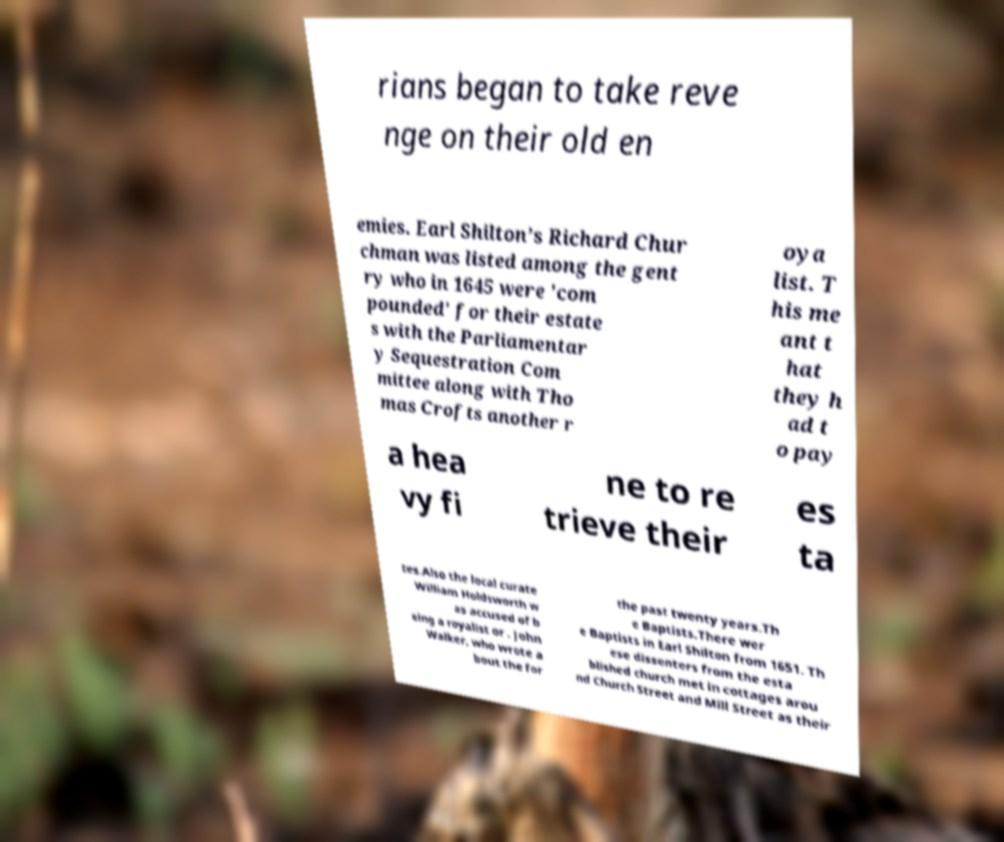Please identify and transcribe the text found in this image. rians began to take reve nge on their old en emies. Earl Shilton’s Richard Chur chman was listed among the gent ry who in 1645 were 'com pounded' for their estate s with the Parliamentar y Sequestration Com mittee along with Tho mas Crofts another r oya list. T his me ant t hat they h ad t o pay a hea vy fi ne to re trieve their es ta tes.Also the local curate William Holdsworth w as accused of b eing a royalist or . John Walker, who wrote a bout the for the past twenty years.Th e Baptists.There wer e Baptists in Earl Shilton from 1651. Th ese dissenters from the esta blished church met in cottages arou nd Church Street and Mill Street as their 